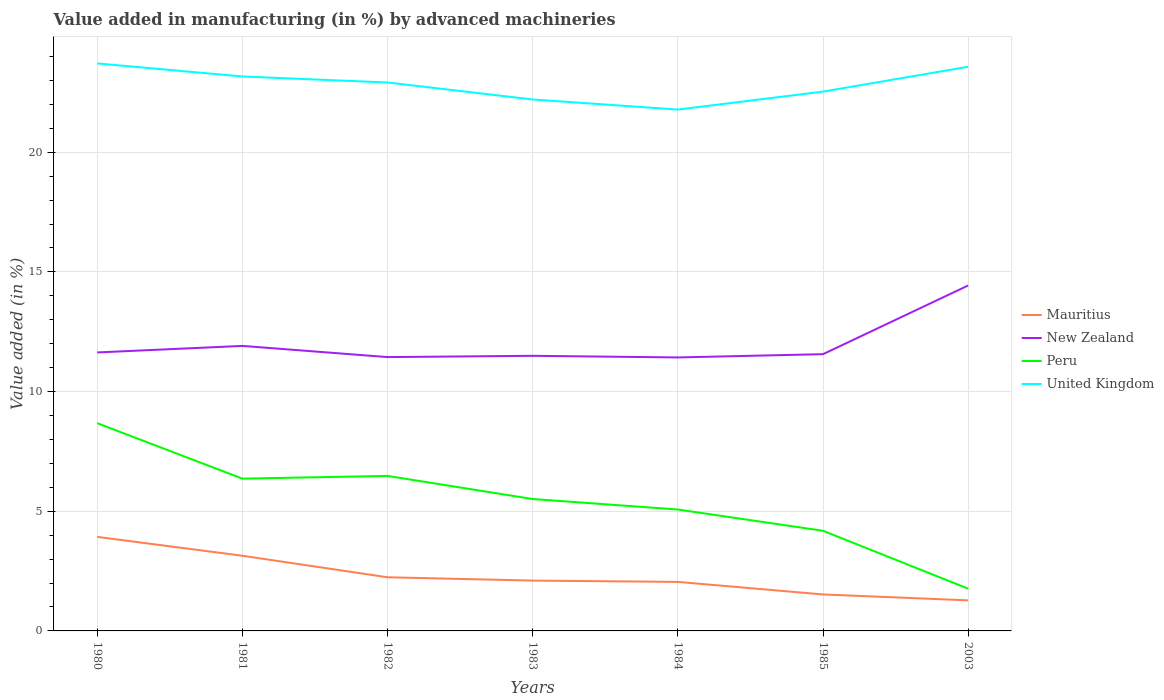Is the number of lines equal to the number of legend labels?
Offer a very short reply. Yes. Across all years, what is the maximum percentage of value added in manufacturing by advanced machineries in United Kingdom?
Give a very brief answer. 21.78. In which year was the percentage of value added in manufacturing by advanced machineries in Mauritius maximum?
Keep it short and to the point. 2003. What is the total percentage of value added in manufacturing by advanced machineries in Mauritius in the graph?
Offer a very short reply. 0.52. What is the difference between the highest and the second highest percentage of value added in manufacturing by advanced machineries in Peru?
Offer a terse response. 6.91. How many lines are there?
Keep it short and to the point. 4. Does the graph contain grids?
Your answer should be compact. Yes. How are the legend labels stacked?
Offer a very short reply. Vertical. What is the title of the graph?
Your answer should be very brief. Value added in manufacturing (in %) by advanced machineries. Does "Senegal" appear as one of the legend labels in the graph?
Provide a short and direct response. No. What is the label or title of the Y-axis?
Ensure brevity in your answer.  Value added (in %). What is the Value added (in %) of Mauritius in 1980?
Offer a very short reply. 3.93. What is the Value added (in %) in New Zealand in 1980?
Offer a terse response. 11.64. What is the Value added (in %) of Peru in 1980?
Give a very brief answer. 8.68. What is the Value added (in %) in United Kingdom in 1980?
Give a very brief answer. 23.71. What is the Value added (in %) of Mauritius in 1981?
Your answer should be very brief. 3.14. What is the Value added (in %) in New Zealand in 1981?
Make the answer very short. 11.91. What is the Value added (in %) in Peru in 1981?
Your answer should be very brief. 6.36. What is the Value added (in %) of United Kingdom in 1981?
Ensure brevity in your answer.  23.17. What is the Value added (in %) of Mauritius in 1982?
Ensure brevity in your answer.  2.24. What is the Value added (in %) in New Zealand in 1982?
Your answer should be compact. 11.44. What is the Value added (in %) of Peru in 1982?
Provide a succinct answer. 6.48. What is the Value added (in %) of United Kingdom in 1982?
Offer a very short reply. 22.91. What is the Value added (in %) in Mauritius in 1983?
Offer a terse response. 2.1. What is the Value added (in %) in New Zealand in 1983?
Your answer should be compact. 11.49. What is the Value added (in %) in Peru in 1983?
Give a very brief answer. 5.51. What is the Value added (in %) of United Kingdom in 1983?
Ensure brevity in your answer.  22.2. What is the Value added (in %) of Mauritius in 1984?
Keep it short and to the point. 2.05. What is the Value added (in %) of New Zealand in 1984?
Ensure brevity in your answer.  11.43. What is the Value added (in %) in Peru in 1984?
Your answer should be very brief. 5.07. What is the Value added (in %) in United Kingdom in 1984?
Make the answer very short. 21.78. What is the Value added (in %) in Mauritius in 1985?
Provide a succinct answer. 1.52. What is the Value added (in %) in New Zealand in 1985?
Offer a terse response. 11.56. What is the Value added (in %) of Peru in 1985?
Offer a terse response. 4.18. What is the Value added (in %) in United Kingdom in 1985?
Provide a short and direct response. 22.53. What is the Value added (in %) in Mauritius in 2003?
Provide a succinct answer. 1.28. What is the Value added (in %) in New Zealand in 2003?
Your answer should be compact. 14.43. What is the Value added (in %) in Peru in 2003?
Your answer should be very brief. 1.77. What is the Value added (in %) in United Kingdom in 2003?
Ensure brevity in your answer.  23.57. Across all years, what is the maximum Value added (in %) of Mauritius?
Offer a terse response. 3.93. Across all years, what is the maximum Value added (in %) in New Zealand?
Your answer should be compact. 14.43. Across all years, what is the maximum Value added (in %) in Peru?
Offer a very short reply. 8.68. Across all years, what is the maximum Value added (in %) of United Kingdom?
Offer a terse response. 23.71. Across all years, what is the minimum Value added (in %) of Mauritius?
Keep it short and to the point. 1.28. Across all years, what is the minimum Value added (in %) of New Zealand?
Give a very brief answer. 11.43. Across all years, what is the minimum Value added (in %) of Peru?
Offer a very short reply. 1.77. Across all years, what is the minimum Value added (in %) in United Kingdom?
Offer a very short reply. 21.78. What is the total Value added (in %) in Mauritius in the graph?
Provide a short and direct response. 16.26. What is the total Value added (in %) in New Zealand in the graph?
Your answer should be very brief. 83.9. What is the total Value added (in %) in Peru in the graph?
Provide a succinct answer. 38.05. What is the total Value added (in %) of United Kingdom in the graph?
Offer a terse response. 159.89. What is the difference between the Value added (in %) in Mauritius in 1980 and that in 1981?
Give a very brief answer. 0.79. What is the difference between the Value added (in %) in New Zealand in 1980 and that in 1981?
Your response must be concise. -0.27. What is the difference between the Value added (in %) in Peru in 1980 and that in 1981?
Your answer should be very brief. 2.32. What is the difference between the Value added (in %) in United Kingdom in 1980 and that in 1981?
Provide a short and direct response. 0.55. What is the difference between the Value added (in %) in Mauritius in 1980 and that in 1982?
Ensure brevity in your answer.  1.69. What is the difference between the Value added (in %) in New Zealand in 1980 and that in 1982?
Offer a terse response. 0.19. What is the difference between the Value added (in %) in Peru in 1980 and that in 1982?
Your response must be concise. 2.2. What is the difference between the Value added (in %) in United Kingdom in 1980 and that in 1982?
Offer a terse response. 0.8. What is the difference between the Value added (in %) of Mauritius in 1980 and that in 1983?
Give a very brief answer. 1.83. What is the difference between the Value added (in %) in New Zealand in 1980 and that in 1983?
Offer a very short reply. 0.14. What is the difference between the Value added (in %) in Peru in 1980 and that in 1983?
Ensure brevity in your answer.  3.17. What is the difference between the Value added (in %) of United Kingdom in 1980 and that in 1983?
Provide a short and direct response. 1.51. What is the difference between the Value added (in %) of Mauritius in 1980 and that in 1984?
Offer a very short reply. 1.88. What is the difference between the Value added (in %) in New Zealand in 1980 and that in 1984?
Make the answer very short. 0.21. What is the difference between the Value added (in %) in Peru in 1980 and that in 1984?
Offer a very short reply. 3.61. What is the difference between the Value added (in %) in United Kingdom in 1980 and that in 1984?
Offer a very short reply. 1.93. What is the difference between the Value added (in %) of Mauritius in 1980 and that in 1985?
Provide a succinct answer. 2.41. What is the difference between the Value added (in %) in New Zealand in 1980 and that in 1985?
Provide a succinct answer. 0.07. What is the difference between the Value added (in %) of Peru in 1980 and that in 1985?
Keep it short and to the point. 4.5. What is the difference between the Value added (in %) in United Kingdom in 1980 and that in 1985?
Offer a terse response. 1.18. What is the difference between the Value added (in %) of Mauritius in 1980 and that in 2003?
Ensure brevity in your answer.  2.65. What is the difference between the Value added (in %) in New Zealand in 1980 and that in 2003?
Offer a terse response. -2.8. What is the difference between the Value added (in %) in Peru in 1980 and that in 2003?
Give a very brief answer. 6.91. What is the difference between the Value added (in %) of United Kingdom in 1980 and that in 2003?
Offer a terse response. 0.14. What is the difference between the Value added (in %) in Mauritius in 1981 and that in 1982?
Keep it short and to the point. 0.9. What is the difference between the Value added (in %) of New Zealand in 1981 and that in 1982?
Provide a short and direct response. 0.47. What is the difference between the Value added (in %) of Peru in 1981 and that in 1982?
Make the answer very short. -0.11. What is the difference between the Value added (in %) of United Kingdom in 1981 and that in 1982?
Your response must be concise. 0.25. What is the difference between the Value added (in %) of Mauritius in 1981 and that in 1983?
Your answer should be very brief. 1.04. What is the difference between the Value added (in %) in New Zealand in 1981 and that in 1983?
Offer a terse response. 0.41. What is the difference between the Value added (in %) of Peru in 1981 and that in 1983?
Ensure brevity in your answer.  0.85. What is the difference between the Value added (in %) of United Kingdom in 1981 and that in 1983?
Your answer should be compact. 0.96. What is the difference between the Value added (in %) in Mauritius in 1981 and that in 1984?
Your answer should be very brief. 1.09. What is the difference between the Value added (in %) in New Zealand in 1981 and that in 1984?
Keep it short and to the point. 0.48. What is the difference between the Value added (in %) in Peru in 1981 and that in 1984?
Ensure brevity in your answer.  1.29. What is the difference between the Value added (in %) in United Kingdom in 1981 and that in 1984?
Offer a very short reply. 1.38. What is the difference between the Value added (in %) of Mauritius in 1981 and that in 1985?
Ensure brevity in your answer.  1.62. What is the difference between the Value added (in %) of New Zealand in 1981 and that in 1985?
Your response must be concise. 0.35. What is the difference between the Value added (in %) of Peru in 1981 and that in 1985?
Offer a very short reply. 2.18. What is the difference between the Value added (in %) in United Kingdom in 1981 and that in 1985?
Provide a succinct answer. 0.63. What is the difference between the Value added (in %) of Mauritius in 1981 and that in 2003?
Provide a succinct answer. 1.86. What is the difference between the Value added (in %) in New Zealand in 1981 and that in 2003?
Give a very brief answer. -2.52. What is the difference between the Value added (in %) in Peru in 1981 and that in 2003?
Ensure brevity in your answer.  4.6. What is the difference between the Value added (in %) of United Kingdom in 1981 and that in 2003?
Offer a very short reply. -0.41. What is the difference between the Value added (in %) in Mauritius in 1982 and that in 1983?
Provide a succinct answer. 0.14. What is the difference between the Value added (in %) of New Zealand in 1982 and that in 1983?
Offer a terse response. -0.05. What is the difference between the Value added (in %) of Peru in 1982 and that in 1983?
Provide a succinct answer. 0.96. What is the difference between the Value added (in %) of United Kingdom in 1982 and that in 1983?
Provide a short and direct response. 0.71. What is the difference between the Value added (in %) in Mauritius in 1982 and that in 1984?
Make the answer very short. 0.19. What is the difference between the Value added (in %) in New Zealand in 1982 and that in 1984?
Provide a succinct answer. 0.01. What is the difference between the Value added (in %) in Peru in 1982 and that in 1984?
Provide a short and direct response. 1.4. What is the difference between the Value added (in %) of United Kingdom in 1982 and that in 1984?
Make the answer very short. 1.13. What is the difference between the Value added (in %) in Mauritius in 1982 and that in 1985?
Your response must be concise. 0.72. What is the difference between the Value added (in %) in New Zealand in 1982 and that in 1985?
Give a very brief answer. -0.12. What is the difference between the Value added (in %) in Peru in 1982 and that in 1985?
Your response must be concise. 2.29. What is the difference between the Value added (in %) of United Kingdom in 1982 and that in 1985?
Give a very brief answer. 0.38. What is the difference between the Value added (in %) in Mauritius in 1982 and that in 2003?
Keep it short and to the point. 0.96. What is the difference between the Value added (in %) of New Zealand in 1982 and that in 2003?
Your answer should be compact. -2.99. What is the difference between the Value added (in %) in Peru in 1982 and that in 2003?
Provide a succinct answer. 4.71. What is the difference between the Value added (in %) in United Kingdom in 1982 and that in 2003?
Your response must be concise. -0.66. What is the difference between the Value added (in %) of Mauritius in 1983 and that in 1984?
Ensure brevity in your answer.  0.05. What is the difference between the Value added (in %) in New Zealand in 1983 and that in 1984?
Your answer should be compact. 0.07. What is the difference between the Value added (in %) of Peru in 1983 and that in 1984?
Provide a succinct answer. 0.44. What is the difference between the Value added (in %) of United Kingdom in 1983 and that in 1984?
Keep it short and to the point. 0.42. What is the difference between the Value added (in %) in Mauritius in 1983 and that in 1985?
Make the answer very short. 0.58. What is the difference between the Value added (in %) of New Zealand in 1983 and that in 1985?
Your answer should be very brief. -0.07. What is the difference between the Value added (in %) of Peru in 1983 and that in 1985?
Offer a very short reply. 1.33. What is the difference between the Value added (in %) in United Kingdom in 1983 and that in 1985?
Your answer should be very brief. -0.33. What is the difference between the Value added (in %) of Mauritius in 1983 and that in 2003?
Keep it short and to the point. 0.83. What is the difference between the Value added (in %) of New Zealand in 1983 and that in 2003?
Your response must be concise. -2.94. What is the difference between the Value added (in %) of Peru in 1983 and that in 2003?
Provide a short and direct response. 3.75. What is the difference between the Value added (in %) of United Kingdom in 1983 and that in 2003?
Provide a short and direct response. -1.37. What is the difference between the Value added (in %) of Mauritius in 1984 and that in 1985?
Give a very brief answer. 0.52. What is the difference between the Value added (in %) in New Zealand in 1984 and that in 1985?
Ensure brevity in your answer.  -0.14. What is the difference between the Value added (in %) of Peru in 1984 and that in 1985?
Your answer should be very brief. 0.89. What is the difference between the Value added (in %) in United Kingdom in 1984 and that in 1985?
Your answer should be compact. -0.75. What is the difference between the Value added (in %) of Mauritius in 1984 and that in 2003?
Provide a succinct answer. 0.77. What is the difference between the Value added (in %) in New Zealand in 1984 and that in 2003?
Provide a succinct answer. -3.01. What is the difference between the Value added (in %) of Peru in 1984 and that in 2003?
Ensure brevity in your answer.  3.31. What is the difference between the Value added (in %) of United Kingdom in 1984 and that in 2003?
Offer a very short reply. -1.79. What is the difference between the Value added (in %) in Mauritius in 1985 and that in 2003?
Provide a succinct answer. 0.25. What is the difference between the Value added (in %) in New Zealand in 1985 and that in 2003?
Ensure brevity in your answer.  -2.87. What is the difference between the Value added (in %) of Peru in 1985 and that in 2003?
Offer a terse response. 2.42. What is the difference between the Value added (in %) in United Kingdom in 1985 and that in 2003?
Make the answer very short. -1.04. What is the difference between the Value added (in %) in Mauritius in 1980 and the Value added (in %) in New Zealand in 1981?
Offer a terse response. -7.98. What is the difference between the Value added (in %) in Mauritius in 1980 and the Value added (in %) in Peru in 1981?
Ensure brevity in your answer.  -2.43. What is the difference between the Value added (in %) in Mauritius in 1980 and the Value added (in %) in United Kingdom in 1981?
Offer a very short reply. -19.24. What is the difference between the Value added (in %) in New Zealand in 1980 and the Value added (in %) in Peru in 1981?
Your response must be concise. 5.27. What is the difference between the Value added (in %) in New Zealand in 1980 and the Value added (in %) in United Kingdom in 1981?
Make the answer very short. -11.53. What is the difference between the Value added (in %) of Peru in 1980 and the Value added (in %) of United Kingdom in 1981?
Offer a terse response. -14.49. What is the difference between the Value added (in %) of Mauritius in 1980 and the Value added (in %) of New Zealand in 1982?
Give a very brief answer. -7.51. What is the difference between the Value added (in %) of Mauritius in 1980 and the Value added (in %) of Peru in 1982?
Make the answer very short. -2.55. What is the difference between the Value added (in %) of Mauritius in 1980 and the Value added (in %) of United Kingdom in 1982?
Give a very brief answer. -18.99. What is the difference between the Value added (in %) in New Zealand in 1980 and the Value added (in %) in Peru in 1982?
Ensure brevity in your answer.  5.16. What is the difference between the Value added (in %) of New Zealand in 1980 and the Value added (in %) of United Kingdom in 1982?
Offer a terse response. -11.28. What is the difference between the Value added (in %) in Peru in 1980 and the Value added (in %) in United Kingdom in 1982?
Provide a short and direct response. -14.23. What is the difference between the Value added (in %) in Mauritius in 1980 and the Value added (in %) in New Zealand in 1983?
Offer a very short reply. -7.57. What is the difference between the Value added (in %) of Mauritius in 1980 and the Value added (in %) of Peru in 1983?
Your response must be concise. -1.58. What is the difference between the Value added (in %) in Mauritius in 1980 and the Value added (in %) in United Kingdom in 1983?
Keep it short and to the point. -18.28. What is the difference between the Value added (in %) of New Zealand in 1980 and the Value added (in %) of Peru in 1983?
Offer a very short reply. 6.12. What is the difference between the Value added (in %) of New Zealand in 1980 and the Value added (in %) of United Kingdom in 1983?
Offer a terse response. -10.57. What is the difference between the Value added (in %) in Peru in 1980 and the Value added (in %) in United Kingdom in 1983?
Offer a very short reply. -13.52. What is the difference between the Value added (in %) in Mauritius in 1980 and the Value added (in %) in New Zealand in 1984?
Your answer should be compact. -7.5. What is the difference between the Value added (in %) of Mauritius in 1980 and the Value added (in %) of Peru in 1984?
Offer a very short reply. -1.14. What is the difference between the Value added (in %) in Mauritius in 1980 and the Value added (in %) in United Kingdom in 1984?
Your response must be concise. -17.85. What is the difference between the Value added (in %) in New Zealand in 1980 and the Value added (in %) in Peru in 1984?
Keep it short and to the point. 6.56. What is the difference between the Value added (in %) of New Zealand in 1980 and the Value added (in %) of United Kingdom in 1984?
Ensure brevity in your answer.  -10.15. What is the difference between the Value added (in %) of Peru in 1980 and the Value added (in %) of United Kingdom in 1984?
Your response must be concise. -13.1. What is the difference between the Value added (in %) in Mauritius in 1980 and the Value added (in %) in New Zealand in 1985?
Offer a terse response. -7.63. What is the difference between the Value added (in %) in Mauritius in 1980 and the Value added (in %) in Peru in 1985?
Offer a very short reply. -0.25. What is the difference between the Value added (in %) in Mauritius in 1980 and the Value added (in %) in United Kingdom in 1985?
Offer a terse response. -18.6. What is the difference between the Value added (in %) in New Zealand in 1980 and the Value added (in %) in Peru in 1985?
Offer a very short reply. 7.45. What is the difference between the Value added (in %) of New Zealand in 1980 and the Value added (in %) of United Kingdom in 1985?
Keep it short and to the point. -10.9. What is the difference between the Value added (in %) in Peru in 1980 and the Value added (in %) in United Kingdom in 1985?
Your answer should be very brief. -13.85. What is the difference between the Value added (in %) in Mauritius in 1980 and the Value added (in %) in New Zealand in 2003?
Keep it short and to the point. -10.5. What is the difference between the Value added (in %) of Mauritius in 1980 and the Value added (in %) of Peru in 2003?
Your answer should be compact. 2.16. What is the difference between the Value added (in %) in Mauritius in 1980 and the Value added (in %) in United Kingdom in 2003?
Your response must be concise. -19.64. What is the difference between the Value added (in %) in New Zealand in 1980 and the Value added (in %) in Peru in 2003?
Offer a terse response. 9.87. What is the difference between the Value added (in %) in New Zealand in 1980 and the Value added (in %) in United Kingdom in 2003?
Keep it short and to the point. -11.94. What is the difference between the Value added (in %) of Peru in 1980 and the Value added (in %) of United Kingdom in 2003?
Make the answer very short. -14.89. What is the difference between the Value added (in %) in Mauritius in 1981 and the Value added (in %) in New Zealand in 1982?
Ensure brevity in your answer.  -8.3. What is the difference between the Value added (in %) of Mauritius in 1981 and the Value added (in %) of Peru in 1982?
Give a very brief answer. -3.34. What is the difference between the Value added (in %) of Mauritius in 1981 and the Value added (in %) of United Kingdom in 1982?
Your answer should be compact. -19.77. What is the difference between the Value added (in %) in New Zealand in 1981 and the Value added (in %) in Peru in 1982?
Keep it short and to the point. 5.43. What is the difference between the Value added (in %) of New Zealand in 1981 and the Value added (in %) of United Kingdom in 1982?
Provide a succinct answer. -11.01. What is the difference between the Value added (in %) of Peru in 1981 and the Value added (in %) of United Kingdom in 1982?
Make the answer very short. -16.55. What is the difference between the Value added (in %) in Mauritius in 1981 and the Value added (in %) in New Zealand in 1983?
Give a very brief answer. -8.35. What is the difference between the Value added (in %) of Mauritius in 1981 and the Value added (in %) of Peru in 1983?
Offer a very short reply. -2.37. What is the difference between the Value added (in %) of Mauritius in 1981 and the Value added (in %) of United Kingdom in 1983?
Keep it short and to the point. -19.06. What is the difference between the Value added (in %) in New Zealand in 1981 and the Value added (in %) in Peru in 1983?
Make the answer very short. 6.4. What is the difference between the Value added (in %) in New Zealand in 1981 and the Value added (in %) in United Kingdom in 1983?
Ensure brevity in your answer.  -10.3. What is the difference between the Value added (in %) of Peru in 1981 and the Value added (in %) of United Kingdom in 1983?
Your answer should be very brief. -15.84. What is the difference between the Value added (in %) of Mauritius in 1981 and the Value added (in %) of New Zealand in 1984?
Provide a succinct answer. -8.29. What is the difference between the Value added (in %) in Mauritius in 1981 and the Value added (in %) in Peru in 1984?
Provide a succinct answer. -1.93. What is the difference between the Value added (in %) in Mauritius in 1981 and the Value added (in %) in United Kingdom in 1984?
Give a very brief answer. -18.64. What is the difference between the Value added (in %) in New Zealand in 1981 and the Value added (in %) in Peru in 1984?
Your answer should be very brief. 6.84. What is the difference between the Value added (in %) of New Zealand in 1981 and the Value added (in %) of United Kingdom in 1984?
Your answer should be compact. -9.87. What is the difference between the Value added (in %) of Peru in 1981 and the Value added (in %) of United Kingdom in 1984?
Keep it short and to the point. -15.42. What is the difference between the Value added (in %) in Mauritius in 1981 and the Value added (in %) in New Zealand in 1985?
Your answer should be compact. -8.42. What is the difference between the Value added (in %) of Mauritius in 1981 and the Value added (in %) of Peru in 1985?
Provide a succinct answer. -1.04. What is the difference between the Value added (in %) of Mauritius in 1981 and the Value added (in %) of United Kingdom in 1985?
Offer a very short reply. -19.39. What is the difference between the Value added (in %) in New Zealand in 1981 and the Value added (in %) in Peru in 1985?
Provide a short and direct response. 7.72. What is the difference between the Value added (in %) of New Zealand in 1981 and the Value added (in %) of United Kingdom in 1985?
Provide a short and direct response. -10.63. What is the difference between the Value added (in %) in Peru in 1981 and the Value added (in %) in United Kingdom in 1985?
Offer a terse response. -16.17. What is the difference between the Value added (in %) in Mauritius in 1981 and the Value added (in %) in New Zealand in 2003?
Your response must be concise. -11.29. What is the difference between the Value added (in %) in Mauritius in 1981 and the Value added (in %) in Peru in 2003?
Provide a short and direct response. 1.38. What is the difference between the Value added (in %) of Mauritius in 1981 and the Value added (in %) of United Kingdom in 2003?
Ensure brevity in your answer.  -20.43. What is the difference between the Value added (in %) in New Zealand in 1981 and the Value added (in %) in Peru in 2003?
Give a very brief answer. 10.14. What is the difference between the Value added (in %) of New Zealand in 1981 and the Value added (in %) of United Kingdom in 2003?
Give a very brief answer. -11.66. What is the difference between the Value added (in %) in Peru in 1981 and the Value added (in %) in United Kingdom in 2003?
Offer a terse response. -17.21. What is the difference between the Value added (in %) of Mauritius in 1982 and the Value added (in %) of New Zealand in 1983?
Provide a succinct answer. -9.25. What is the difference between the Value added (in %) of Mauritius in 1982 and the Value added (in %) of Peru in 1983?
Your response must be concise. -3.27. What is the difference between the Value added (in %) in Mauritius in 1982 and the Value added (in %) in United Kingdom in 1983?
Offer a terse response. -19.96. What is the difference between the Value added (in %) in New Zealand in 1982 and the Value added (in %) in Peru in 1983?
Provide a short and direct response. 5.93. What is the difference between the Value added (in %) in New Zealand in 1982 and the Value added (in %) in United Kingdom in 1983?
Give a very brief answer. -10.76. What is the difference between the Value added (in %) of Peru in 1982 and the Value added (in %) of United Kingdom in 1983?
Give a very brief answer. -15.73. What is the difference between the Value added (in %) in Mauritius in 1982 and the Value added (in %) in New Zealand in 1984?
Offer a terse response. -9.19. What is the difference between the Value added (in %) in Mauritius in 1982 and the Value added (in %) in Peru in 1984?
Make the answer very short. -2.83. What is the difference between the Value added (in %) in Mauritius in 1982 and the Value added (in %) in United Kingdom in 1984?
Ensure brevity in your answer.  -19.54. What is the difference between the Value added (in %) in New Zealand in 1982 and the Value added (in %) in Peru in 1984?
Ensure brevity in your answer.  6.37. What is the difference between the Value added (in %) of New Zealand in 1982 and the Value added (in %) of United Kingdom in 1984?
Your answer should be compact. -10.34. What is the difference between the Value added (in %) in Peru in 1982 and the Value added (in %) in United Kingdom in 1984?
Provide a succinct answer. -15.31. What is the difference between the Value added (in %) in Mauritius in 1982 and the Value added (in %) in New Zealand in 1985?
Provide a short and direct response. -9.32. What is the difference between the Value added (in %) of Mauritius in 1982 and the Value added (in %) of Peru in 1985?
Give a very brief answer. -1.94. What is the difference between the Value added (in %) in Mauritius in 1982 and the Value added (in %) in United Kingdom in 1985?
Provide a short and direct response. -20.29. What is the difference between the Value added (in %) in New Zealand in 1982 and the Value added (in %) in Peru in 1985?
Ensure brevity in your answer.  7.26. What is the difference between the Value added (in %) in New Zealand in 1982 and the Value added (in %) in United Kingdom in 1985?
Keep it short and to the point. -11.09. What is the difference between the Value added (in %) of Peru in 1982 and the Value added (in %) of United Kingdom in 1985?
Your response must be concise. -16.06. What is the difference between the Value added (in %) in Mauritius in 1982 and the Value added (in %) in New Zealand in 2003?
Give a very brief answer. -12.19. What is the difference between the Value added (in %) in Mauritius in 1982 and the Value added (in %) in Peru in 2003?
Offer a terse response. 0.48. What is the difference between the Value added (in %) of Mauritius in 1982 and the Value added (in %) of United Kingdom in 2003?
Provide a succinct answer. -21.33. What is the difference between the Value added (in %) of New Zealand in 1982 and the Value added (in %) of Peru in 2003?
Your answer should be compact. 9.68. What is the difference between the Value added (in %) in New Zealand in 1982 and the Value added (in %) in United Kingdom in 2003?
Make the answer very short. -12.13. What is the difference between the Value added (in %) of Peru in 1982 and the Value added (in %) of United Kingdom in 2003?
Ensure brevity in your answer.  -17.1. What is the difference between the Value added (in %) in Mauritius in 1983 and the Value added (in %) in New Zealand in 1984?
Offer a very short reply. -9.32. What is the difference between the Value added (in %) in Mauritius in 1983 and the Value added (in %) in Peru in 1984?
Offer a terse response. -2.97. What is the difference between the Value added (in %) of Mauritius in 1983 and the Value added (in %) of United Kingdom in 1984?
Provide a short and direct response. -19.68. What is the difference between the Value added (in %) in New Zealand in 1983 and the Value added (in %) in Peru in 1984?
Ensure brevity in your answer.  6.42. What is the difference between the Value added (in %) of New Zealand in 1983 and the Value added (in %) of United Kingdom in 1984?
Keep it short and to the point. -10.29. What is the difference between the Value added (in %) of Peru in 1983 and the Value added (in %) of United Kingdom in 1984?
Offer a terse response. -16.27. What is the difference between the Value added (in %) of Mauritius in 1983 and the Value added (in %) of New Zealand in 1985?
Your answer should be compact. -9.46. What is the difference between the Value added (in %) of Mauritius in 1983 and the Value added (in %) of Peru in 1985?
Offer a terse response. -2.08. What is the difference between the Value added (in %) of Mauritius in 1983 and the Value added (in %) of United Kingdom in 1985?
Your response must be concise. -20.43. What is the difference between the Value added (in %) in New Zealand in 1983 and the Value added (in %) in Peru in 1985?
Keep it short and to the point. 7.31. What is the difference between the Value added (in %) in New Zealand in 1983 and the Value added (in %) in United Kingdom in 1985?
Your answer should be compact. -11.04. What is the difference between the Value added (in %) of Peru in 1983 and the Value added (in %) of United Kingdom in 1985?
Ensure brevity in your answer.  -17.02. What is the difference between the Value added (in %) in Mauritius in 1983 and the Value added (in %) in New Zealand in 2003?
Provide a succinct answer. -12.33. What is the difference between the Value added (in %) of Mauritius in 1983 and the Value added (in %) of Peru in 2003?
Provide a succinct answer. 0.34. What is the difference between the Value added (in %) of Mauritius in 1983 and the Value added (in %) of United Kingdom in 2003?
Provide a succinct answer. -21.47. What is the difference between the Value added (in %) in New Zealand in 1983 and the Value added (in %) in Peru in 2003?
Keep it short and to the point. 9.73. What is the difference between the Value added (in %) of New Zealand in 1983 and the Value added (in %) of United Kingdom in 2003?
Ensure brevity in your answer.  -12.08. What is the difference between the Value added (in %) of Peru in 1983 and the Value added (in %) of United Kingdom in 2003?
Your response must be concise. -18.06. What is the difference between the Value added (in %) in Mauritius in 1984 and the Value added (in %) in New Zealand in 1985?
Provide a succinct answer. -9.51. What is the difference between the Value added (in %) of Mauritius in 1984 and the Value added (in %) of Peru in 1985?
Your answer should be compact. -2.14. What is the difference between the Value added (in %) in Mauritius in 1984 and the Value added (in %) in United Kingdom in 1985?
Provide a succinct answer. -20.49. What is the difference between the Value added (in %) in New Zealand in 1984 and the Value added (in %) in Peru in 1985?
Your answer should be compact. 7.24. What is the difference between the Value added (in %) of New Zealand in 1984 and the Value added (in %) of United Kingdom in 1985?
Your response must be concise. -11.11. What is the difference between the Value added (in %) of Peru in 1984 and the Value added (in %) of United Kingdom in 1985?
Give a very brief answer. -17.46. What is the difference between the Value added (in %) in Mauritius in 1984 and the Value added (in %) in New Zealand in 2003?
Your answer should be very brief. -12.38. What is the difference between the Value added (in %) in Mauritius in 1984 and the Value added (in %) in Peru in 2003?
Provide a succinct answer. 0.28. What is the difference between the Value added (in %) of Mauritius in 1984 and the Value added (in %) of United Kingdom in 2003?
Make the answer very short. -21.52. What is the difference between the Value added (in %) in New Zealand in 1984 and the Value added (in %) in Peru in 2003?
Offer a terse response. 9.66. What is the difference between the Value added (in %) in New Zealand in 1984 and the Value added (in %) in United Kingdom in 2003?
Make the answer very short. -12.15. What is the difference between the Value added (in %) in Peru in 1984 and the Value added (in %) in United Kingdom in 2003?
Provide a succinct answer. -18.5. What is the difference between the Value added (in %) of Mauritius in 1985 and the Value added (in %) of New Zealand in 2003?
Keep it short and to the point. -12.91. What is the difference between the Value added (in %) of Mauritius in 1985 and the Value added (in %) of Peru in 2003?
Offer a terse response. -0.24. What is the difference between the Value added (in %) in Mauritius in 1985 and the Value added (in %) in United Kingdom in 2003?
Make the answer very short. -22.05. What is the difference between the Value added (in %) of New Zealand in 1985 and the Value added (in %) of Peru in 2003?
Give a very brief answer. 9.8. What is the difference between the Value added (in %) of New Zealand in 1985 and the Value added (in %) of United Kingdom in 2003?
Provide a succinct answer. -12.01. What is the difference between the Value added (in %) of Peru in 1985 and the Value added (in %) of United Kingdom in 2003?
Provide a short and direct response. -19.39. What is the average Value added (in %) in Mauritius per year?
Your answer should be compact. 2.32. What is the average Value added (in %) in New Zealand per year?
Give a very brief answer. 11.99. What is the average Value added (in %) of Peru per year?
Ensure brevity in your answer.  5.44. What is the average Value added (in %) of United Kingdom per year?
Your response must be concise. 22.84. In the year 1980, what is the difference between the Value added (in %) of Mauritius and Value added (in %) of New Zealand?
Make the answer very short. -7.71. In the year 1980, what is the difference between the Value added (in %) in Mauritius and Value added (in %) in Peru?
Keep it short and to the point. -4.75. In the year 1980, what is the difference between the Value added (in %) in Mauritius and Value added (in %) in United Kingdom?
Ensure brevity in your answer.  -19.78. In the year 1980, what is the difference between the Value added (in %) of New Zealand and Value added (in %) of Peru?
Your answer should be very brief. 2.96. In the year 1980, what is the difference between the Value added (in %) of New Zealand and Value added (in %) of United Kingdom?
Your answer should be very brief. -12.08. In the year 1980, what is the difference between the Value added (in %) of Peru and Value added (in %) of United Kingdom?
Give a very brief answer. -15.03. In the year 1981, what is the difference between the Value added (in %) of Mauritius and Value added (in %) of New Zealand?
Offer a very short reply. -8.77. In the year 1981, what is the difference between the Value added (in %) in Mauritius and Value added (in %) in Peru?
Your response must be concise. -3.22. In the year 1981, what is the difference between the Value added (in %) in Mauritius and Value added (in %) in United Kingdom?
Provide a succinct answer. -20.03. In the year 1981, what is the difference between the Value added (in %) in New Zealand and Value added (in %) in Peru?
Offer a very short reply. 5.55. In the year 1981, what is the difference between the Value added (in %) of New Zealand and Value added (in %) of United Kingdom?
Make the answer very short. -11.26. In the year 1981, what is the difference between the Value added (in %) of Peru and Value added (in %) of United Kingdom?
Provide a short and direct response. -16.8. In the year 1982, what is the difference between the Value added (in %) in Mauritius and Value added (in %) in New Zealand?
Your response must be concise. -9.2. In the year 1982, what is the difference between the Value added (in %) in Mauritius and Value added (in %) in Peru?
Your answer should be very brief. -4.24. In the year 1982, what is the difference between the Value added (in %) of Mauritius and Value added (in %) of United Kingdom?
Make the answer very short. -20.67. In the year 1982, what is the difference between the Value added (in %) in New Zealand and Value added (in %) in Peru?
Make the answer very short. 4.97. In the year 1982, what is the difference between the Value added (in %) in New Zealand and Value added (in %) in United Kingdom?
Make the answer very short. -11.47. In the year 1982, what is the difference between the Value added (in %) of Peru and Value added (in %) of United Kingdom?
Keep it short and to the point. -16.44. In the year 1983, what is the difference between the Value added (in %) in Mauritius and Value added (in %) in New Zealand?
Offer a terse response. -9.39. In the year 1983, what is the difference between the Value added (in %) of Mauritius and Value added (in %) of Peru?
Your response must be concise. -3.41. In the year 1983, what is the difference between the Value added (in %) of Mauritius and Value added (in %) of United Kingdom?
Provide a short and direct response. -20.1. In the year 1983, what is the difference between the Value added (in %) of New Zealand and Value added (in %) of Peru?
Offer a terse response. 5.98. In the year 1983, what is the difference between the Value added (in %) of New Zealand and Value added (in %) of United Kingdom?
Ensure brevity in your answer.  -10.71. In the year 1983, what is the difference between the Value added (in %) in Peru and Value added (in %) in United Kingdom?
Provide a succinct answer. -16.69. In the year 1984, what is the difference between the Value added (in %) of Mauritius and Value added (in %) of New Zealand?
Your answer should be compact. -9.38. In the year 1984, what is the difference between the Value added (in %) of Mauritius and Value added (in %) of Peru?
Your answer should be compact. -3.02. In the year 1984, what is the difference between the Value added (in %) of Mauritius and Value added (in %) of United Kingdom?
Keep it short and to the point. -19.74. In the year 1984, what is the difference between the Value added (in %) in New Zealand and Value added (in %) in Peru?
Your response must be concise. 6.35. In the year 1984, what is the difference between the Value added (in %) in New Zealand and Value added (in %) in United Kingdom?
Make the answer very short. -10.36. In the year 1984, what is the difference between the Value added (in %) of Peru and Value added (in %) of United Kingdom?
Offer a very short reply. -16.71. In the year 1985, what is the difference between the Value added (in %) of Mauritius and Value added (in %) of New Zealand?
Your answer should be compact. -10.04. In the year 1985, what is the difference between the Value added (in %) of Mauritius and Value added (in %) of Peru?
Your answer should be very brief. -2.66. In the year 1985, what is the difference between the Value added (in %) of Mauritius and Value added (in %) of United Kingdom?
Your answer should be compact. -21.01. In the year 1985, what is the difference between the Value added (in %) in New Zealand and Value added (in %) in Peru?
Provide a short and direct response. 7.38. In the year 1985, what is the difference between the Value added (in %) of New Zealand and Value added (in %) of United Kingdom?
Ensure brevity in your answer.  -10.97. In the year 1985, what is the difference between the Value added (in %) of Peru and Value added (in %) of United Kingdom?
Your answer should be very brief. -18.35. In the year 2003, what is the difference between the Value added (in %) of Mauritius and Value added (in %) of New Zealand?
Give a very brief answer. -13.16. In the year 2003, what is the difference between the Value added (in %) of Mauritius and Value added (in %) of Peru?
Ensure brevity in your answer.  -0.49. In the year 2003, what is the difference between the Value added (in %) of Mauritius and Value added (in %) of United Kingdom?
Offer a terse response. -22.3. In the year 2003, what is the difference between the Value added (in %) of New Zealand and Value added (in %) of Peru?
Your response must be concise. 12.67. In the year 2003, what is the difference between the Value added (in %) of New Zealand and Value added (in %) of United Kingdom?
Keep it short and to the point. -9.14. In the year 2003, what is the difference between the Value added (in %) in Peru and Value added (in %) in United Kingdom?
Keep it short and to the point. -21.81. What is the ratio of the Value added (in %) in Mauritius in 1980 to that in 1981?
Keep it short and to the point. 1.25. What is the ratio of the Value added (in %) in New Zealand in 1980 to that in 1981?
Your answer should be compact. 0.98. What is the ratio of the Value added (in %) in Peru in 1980 to that in 1981?
Make the answer very short. 1.36. What is the ratio of the Value added (in %) in United Kingdom in 1980 to that in 1981?
Give a very brief answer. 1.02. What is the ratio of the Value added (in %) in Mauritius in 1980 to that in 1982?
Offer a very short reply. 1.75. What is the ratio of the Value added (in %) of New Zealand in 1980 to that in 1982?
Offer a terse response. 1.02. What is the ratio of the Value added (in %) of Peru in 1980 to that in 1982?
Offer a terse response. 1.34. What is the ratio of the Value added (in %) in United Kingdom in 1980 to that in 1982?
Offer a terse response. 1.03. What is the ratio of the Value added (in %) of Mauritius in 1980 to that in 1983?
Keep it short and to the point. 1.87. What is the ratio of the Value added (in %) of New Zealand in 1980 to that in 1983?
Make the answer very short. 1.01. What is the ratio of the Value added (in %) of Peru in 1980 to that in 1983?
Your response must be concise. 1.58. What is the ratio of the Value added (in %) in United Kingdom in 1980 to that in 1983?
Your answer should be compact. 1.07. What is the ratio of the Value added (in %) in Mauritius in 1980 to that in 1984?
Offer a terse response. 1.92. What is the ratio of the Value added (in %) in New Zealand in 1980 to that in 1984?
Give a very brief answer. 1.02. What is the ratio of the Value added (in %) in Peru in 1980 to that in 1984?
Keep it short and to the point. 1.71. What is the ratio of the Value added (in %) of United Kingdom in 1980 to that in 1984?
Your response must be concise. 1.09. What is the ratio of the Value added (in %) of Mauritius in 1980 to that in 1985?
Provide a short and direct response. 2.58. What is the ratio of the Value added (in %) of New Zealand in 1980 to that in 1985?
Ensure brevity in your answer.  1.01. What is the ratio of the Value added (in %) in Peru in 1980 to that in 1985?
Your answer should be compact. 2.07. What is the ratio of the Value added (in %) of United Kingdom in 1980 to that in 1985?
Provide a succinct answer. 1.05. What is the ratio of the Value added (in %) in Mauritius in 1980 to that in 2003?
Make the answer very short. 3.08. What is the ratio of the Value added (in %) of New Zealand in 1980 to that in 2003?
Keep it short and to the point. 0.81. What is the ratio of the Value added (in %) of Peru in 1980 to that in 2003?
Ensure brevity in your answer.  4.92. What is the ratio of the Value added (in %) in United Kingdom in 1980 to that in 2003?
Your answer should be compact. 1.01. What is the ratio of the Value added (in %) in Mauritius in 1981 to that in 1982?
Ensure brevity in your answer.  1.4. What is the ratio of the Value added (in %) in New Zealand in 1981 to that in 1982?
Your answer should be compact. 1.04. What is the ratio of the Value added (in %) of Peru in 1981 to that in 1982?
Provide a succinct answer. 0.98. What is the ratio of the Value added (in %) of Mauritius in 1981 to that in 1983?
Ensure brevity in your answer.  1.49. What is the ratio of the Value added (in %) in New Zealand in 1981 to that in 1983?
Ensure brevity in your answer.  1.04. What is the ratio of the Value added (in %) of Peru in 1981 to that in 1983?
Give a very brief answer. 1.15. What is the ratio of the Value added (in %) of United Kingdom in 1981 to that in 1983?
Make the answer very short. 1.04. What is the ratio of the Value added (in %) in Mauritius in 1981 to that in 1984?
Provide a short and direct response. 1.53. What is the ratio of the Value added (in %) in New Zealand in 1981 to that in 1984?
Your response must be concise. 1.04. What is the ratio of the Value added (in %) of Peru in 1981 to that in 1984?
Keep it short and to the point. 1.25. What is the ratio of the Value added (in %) of United Kingdom in 1981 to that in 1984?
Keep it short and to the point. 1.06. What is the ratio of the Value added (in %) of Mauritius in 1981 to that in 1985?
Offer a very short reply. 2.06. What is the ratio of the Value added (in %) in New Zealand in 1981 to that in 1985?
Make the answer very short. 1.03. What is the ratio of the Value added (in %) in Peru in 1981 to that in 1985?
Keep it short and to the point. 1.52. What is the ratio of the Value added (in %) in United Kingdom in 1981 to that in 1985?
Your response must be concise. 1.03. What is the ratio of the Value added (in %) of Mauritius in 1981 to that in 2003?
Keep it short and to the point. 2.46. What is the ratio of the Value added (in %) in New Zealand in 1981 to that in 2003?
Keep it short and to the point. 0.83. What is the ratio of the Value added (in %) in Peru in 1981 to that in 2003?
Provide a short and direct response. 3.6. What is the ratio of the Value added (in %) of United Kingdom in 1981 to that in 2003?
Offer a terse response. 0.98. What is the ratio of the Value added (in %) in Mauritius in 1982 to that in 1983?
Your response must be concise. 1.07. What is the ratio of the Value added (in %) of New Zealand in 1982 to that in 1983?
Offer a terse response. 1. What is the ratio of the Value added (in %) in Peru in 1982 to that in 1983?
Provide a succinct answer. 1.18. What is the ratio of the Value added (in %) of United Kingdom in 1982 to that in 1983?
Your answer should be very brief. 1.03. What is the ratio of the Value added (in %) in Mauritius in 1982 to that in 1984?
Your answer should be very brief. 1.09. What is the ratio of the Value added (in %) in New Zealand in 1982 to that in 1984?
Give a very brief answer. 1. What is the ratio of the Value added (in %) of Peru in 1982 to that in 1984?
Your response must be concise. 1.28. What is the ratio of the Value added (in %) of United Kingdom in 1982 to that in 1984?
Keep it short and to the point. 1.05. What is the ratio of the Value added (in %) in Mauritius in 1982 to that in 1985?
Your response must be concise. 1.47. What is the ratio of the Value added (in %) in New Zealand in 1982 to that in 1985?
Your answer should be very brief. 0.99. What is the ratio of the Value added (in %) in Peru in 1982 to that in 1985?
Make the answer very short. 1.55. What is the ratio of the Value added (in %) of United Kingdom in 1982 to that in 1985?
Your answer should be very brief. 1.02. What is the ratio of the Value added (in %) in Mauritius in 1982 to that in 2003?
Your answer should be compact. 1.75. What is the ratio of the Value added (in %) in New Zealand in 1982 to that in 2003?
Your response must be concise. 0.79. What is the ratio of the Value added (in %) in Peru in 1982 to that in 2003?
Your response must be concise. 3.67. What is the ratio of the Value added (in %) of United Kingdom in 1982 to that in 2003?
Your response must be concise. 0.97. What is the ratio of the Value added (in %) in Mauritius in 1983 to that in 1984?
Keep it short and to the point. 1.03. What is the ratio of the Value added (in %) in New Zealand in 1983 to that in 1984?
Keep it short and to the point. 1.01. What is the ratio of the Value added (in %) of Peru in 1983 to that in 1984?
Provide a succinct answer. 1.09. What is the ratio of the Value added (in %) of United Kingdom in 1983 to that in 1984?
Provide a succinct answer. 1.02. What is the ratio of the Value added (in %) in Mauritius in 1983 to that in 1985?
Ensure brevity in your answer.  1.38. What is the ratio of the Value added (in %) of New Zealand in 1983 to that in 1985?
Provide a succinct answer. 0.99. What is the ratio of the Value added (in %) in Peru in 1983 to that in 1985?
Your response must be concise. 1.32. What is the ratio of the Value added (in %) of United Kingdom in 1983 to that in 1985?
Offer a very short reply. 0.99. What is the ratio of the Value added (in %) of Mauritius in 1983 to that in 2003?
Provide a short and direct response. 1.65. What is the ratio of the Value added (in %) in New Zealand in 1983 to that in 2003?
Make the answer very short. 0.8. What is the ratio of the Value added (in %) of Peru in 1983 to that in 2003?
Keep it short and to the point. 3.12. What is the ratio of the Value added (in %) of United Kingdom in 1983 to that in 2003?
Keep it short and to the point. 0.94. What is the ratio of the Value added (in %) in Mauritius in 1984 to that in 1985?
Keep it short and to the point. 1.34. What is the ratio of the Value added (in %) in Peru in 1984 to that in 1985?
Offer a terse response. 1.21. What is the ratio of the Value added (in %) of United Kingdom in 1984 to that in 1985?
Offer a very short reply. 0.97. What is the ratio of the Value added (in %) in Mauritius in 1984 to that in 2003?
Your answer should be very brief. 1.6. What is the ratio of the Value added (in %) in New Zealand in 1984 to that in 2003?
Your answer should be compact. 0.79. What is the ratio of the Value added (in %) of Peru in 1984 to that in 2003?
Ensure brevity in your answer.  2.87. What is the ratio of the Value added (in %) of United Kingdom in 1984 to that in 2003?
Give a very brief answer. 0.92. What is the ratio of the Value added (in %) in Mauritius in 1985 to that in 2003?
Ensure brevity in your answer.  1.19. What is the ratio of the Value added (in %) of New Zealand in 1985 to that in 2003?
Offer a very short reply. 0.8. What is the ratio of the Value added (in %) in Peru in 1985 to that in 2003?
Your answer should be compact. 2.37. What is the ratio of the Value added (in %) of United Kingdom in 1985 to that in 2003?
Keep it short and to the point. 0.96. What is the difference between the highest and the second highest Value added (in %) of Mauritius?
Offer a terse response. 0.79. What is the difference between the highest and the second highest Value added (in %) in New Zealand?
Give a very brief answer. 2.52. What is the difference between the highest and the second highest Value added (in %) of Peru?
Your response must be concise. 2.2. What is the difference between the highest and the second highest Value added (in %) in United Kingdom?
Your answer should be compact. 0.14. What is the difference between the highest and the lowest Value added (in %) in Mauritius?
Offer a very short reply. 2.65. What is the difference between the highest and the lowest Value added (in %) in New Zealand?
Ensure brevity in your answer.  3.01. What is the difference between the highest and the lowest Value added (in %) in Peru?
Offer a very short reply. 6.91. What is the difference between the highest and the lowest Value added (in %) in United Kingdom?
Your answer should be compact. 1.93. 